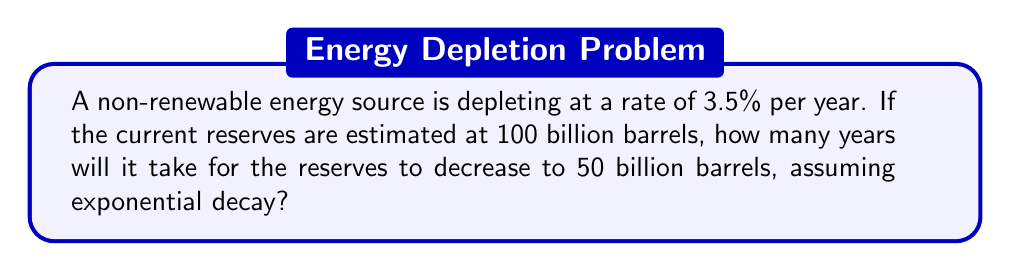Solve this math problem. Let's approach this step-by-step:

1) The exponential decay formula is:
   $$A = A_0 \cdot (1-r)^t$$
   where $A$ is the final amount, $A_0$ is the initial amount, $r$ is the decay rate, and $t$ is the time.

2) We know:
   $A_0 = 100$ billion barrels
   $A = 50$ billion barrels
   $r = 3.5\% = 0.035$

3) Plugging these into the formula:
   $$50 = 100 \cdot (1-0.035)^t$$

4) Dividing both sides by 100:
   $$0.5 = (1-0.035)^t$$

5) Taking the natural log of both sides:
   $$\ln(0.5) = t \cdot \ln(1-0.035)$$

6) Solving for $t$:
   $$t = \frac{\ln(0.5)}{\ln(1-0.035)}$$

7) Using a calculator:
   $$t = \frac{\ln(0.5)}{\ln(0.965)} \approx 19.49$$

8) Rounding up to the nearest whole year:
   $t = 20$ years

This aligns with the renewable energy expert's perspective, highlighting the finite nature of non-renewable resources and the urgency for sustainable alternatives.
Answer: 20 years 